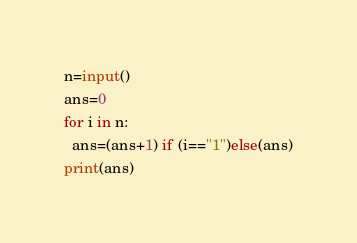<code> <loc_0><loc_0><loc_500><loc_500><_Python_>n=input()
ans=0
for i in n:
  ans=(ans+1) if (i=="1")else(ans)
print(ans)
</code> 